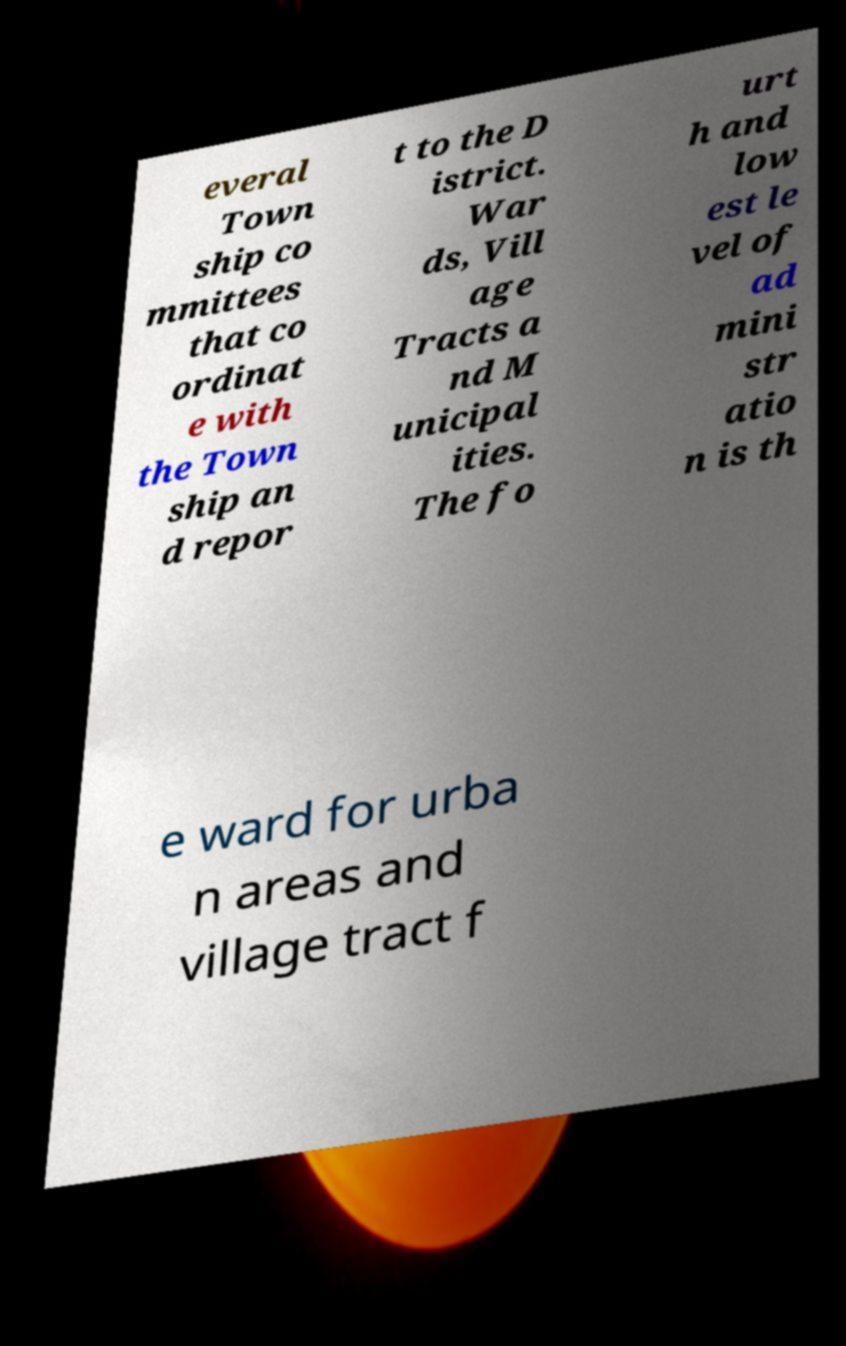Please identify and transcribe the text found in this image. everal Town ship co mmittees that co ordinat e with the Town ship an d repor t to the D istrict. War ds, Vill age Tracts a nd M unicipal ities. The fo urt h and low est le vel of ad mini str atio n is th e ward for urba n areas and village tract f 